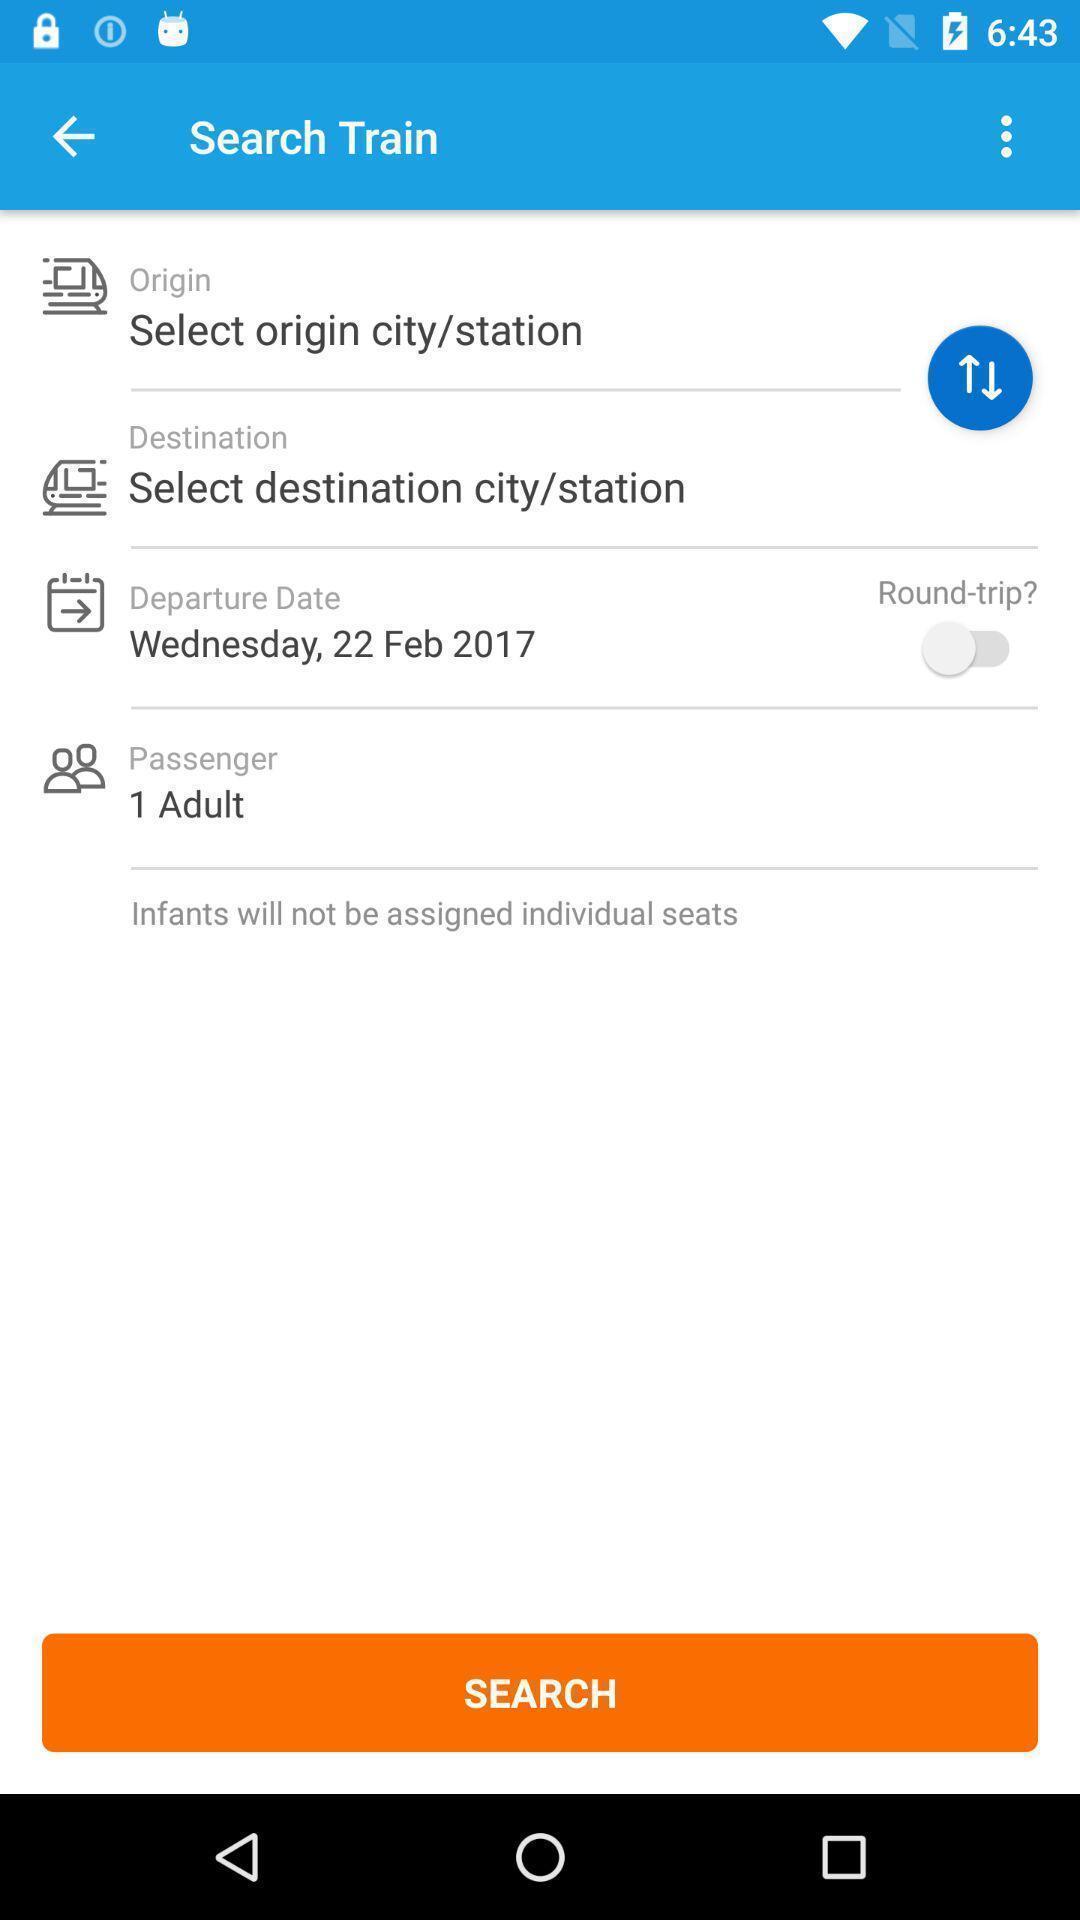Give me a narrative description of this picture. Screen displaying the train ticket information. 